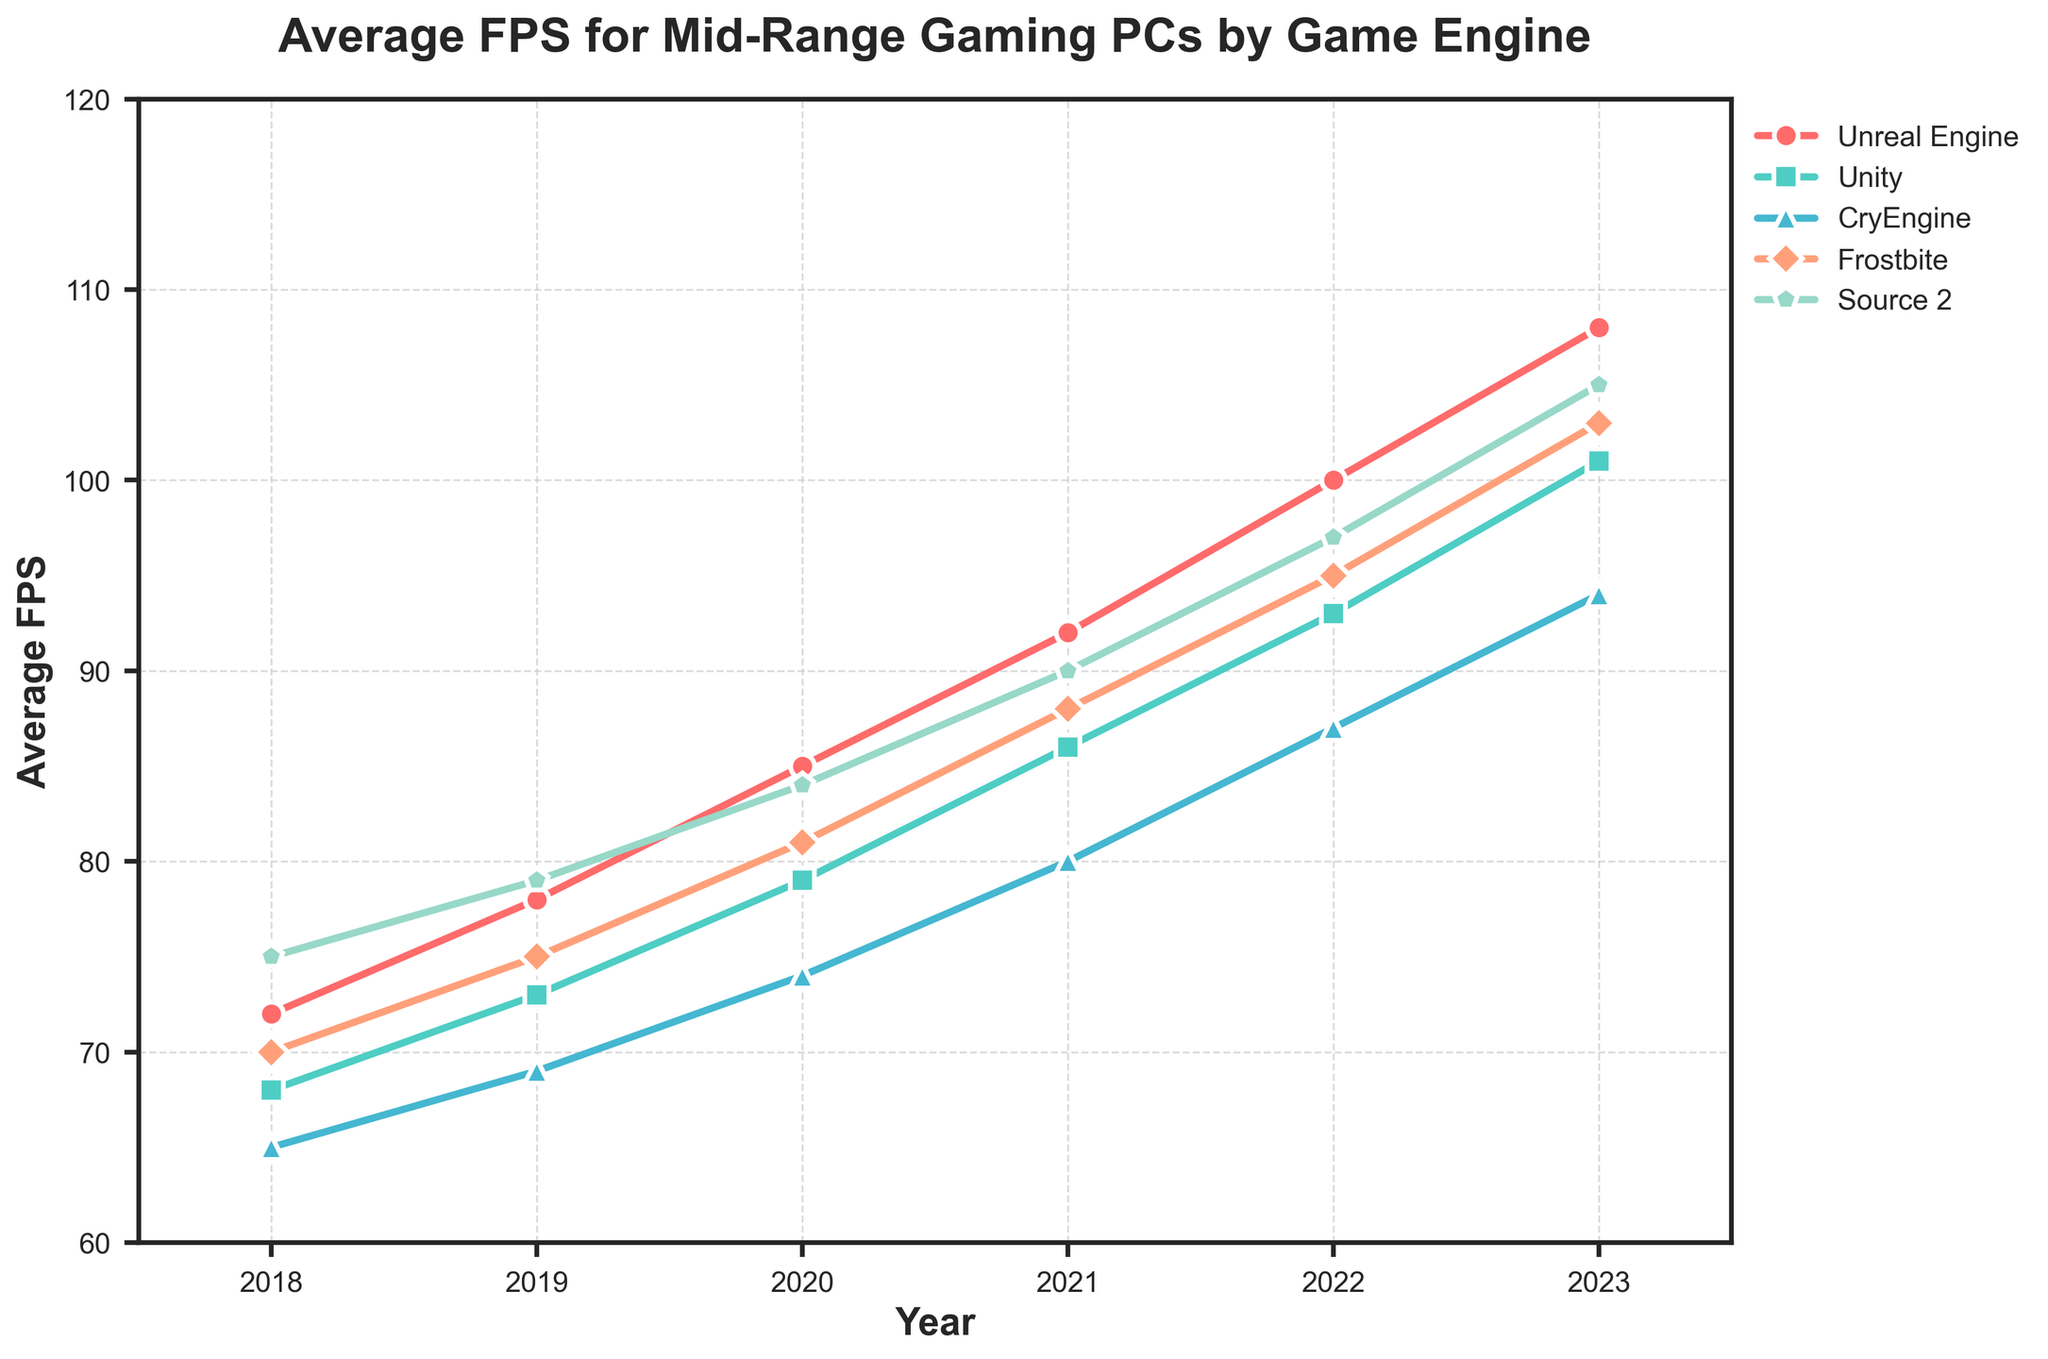What was the average FPS for the Unity engine in 2019? Look at the line corresponding to Unity and find its value in 2019. It is 73 FPS.
Answer: 73 How has the average FPS for the CryEngine changed from 2018 to 2023? Find the CryEngine values for 2018 and 2023 and calculate the difference: 94 - 65 = 29.
Answer: Increased by 29 FPS Which game engine had the highest average FPS in 2021? Look at the lines and determine which one peaks highest in 2021. Source 2 has an FPS of 90, which is the highest.
Answer: Source 2 Did any game engine's average FPS decrease at any point in time during the given years? Visually inspect the graph and check if any line dips at any point; however all lines show an increase, none decrease.
Answer: No Which two game engines had the closest average FPS in 2020? Compare the values of each engine in 2020: Unity (79) and CryEngine (74) have the smallest difference (5).
Answer: Unity and CryEngine By how many FPS did the Frostbite engine's average FPS increase from 2019 to 2022? Find the Frostbite values for 2019 and 2022 and calculate the difference: 95 - 75 = 20.
Answer: Increased by 20 FPS What's the difference in average FPS between Unreal Engine and Source 2 in 2023? Find the values for both engines in 2023 (Unreal Engine = 108, Source 2 = 105) and calculate the difference: 108 - 105 = 3.
Answer: 3 FPS Which year saw the highest collective average FPS across all game engines? Sum the FPS values for all engines in each year and compare. The collective FPS is highest in 2023: 108 + 101 + 94 + 103 + 105 = 511.
Answer: 2023 What is the average FPS improvement per year for Unity from 2018 to 2023? Calculate the total increase for Unity (101 - 68 = 33) and divide by the number of years (5): 33/5 = 6.6
Answer: 6.6 FPS per year How many game engines had an average FPS of 80 or more in 2021? Look at the FPS values for each engine in 2021 and count those equal to or greater than 80: Unreal Engine (92), Unity (86), CryEngine (80), Frostbite (88), Source 2 (90).
Answer: 5 